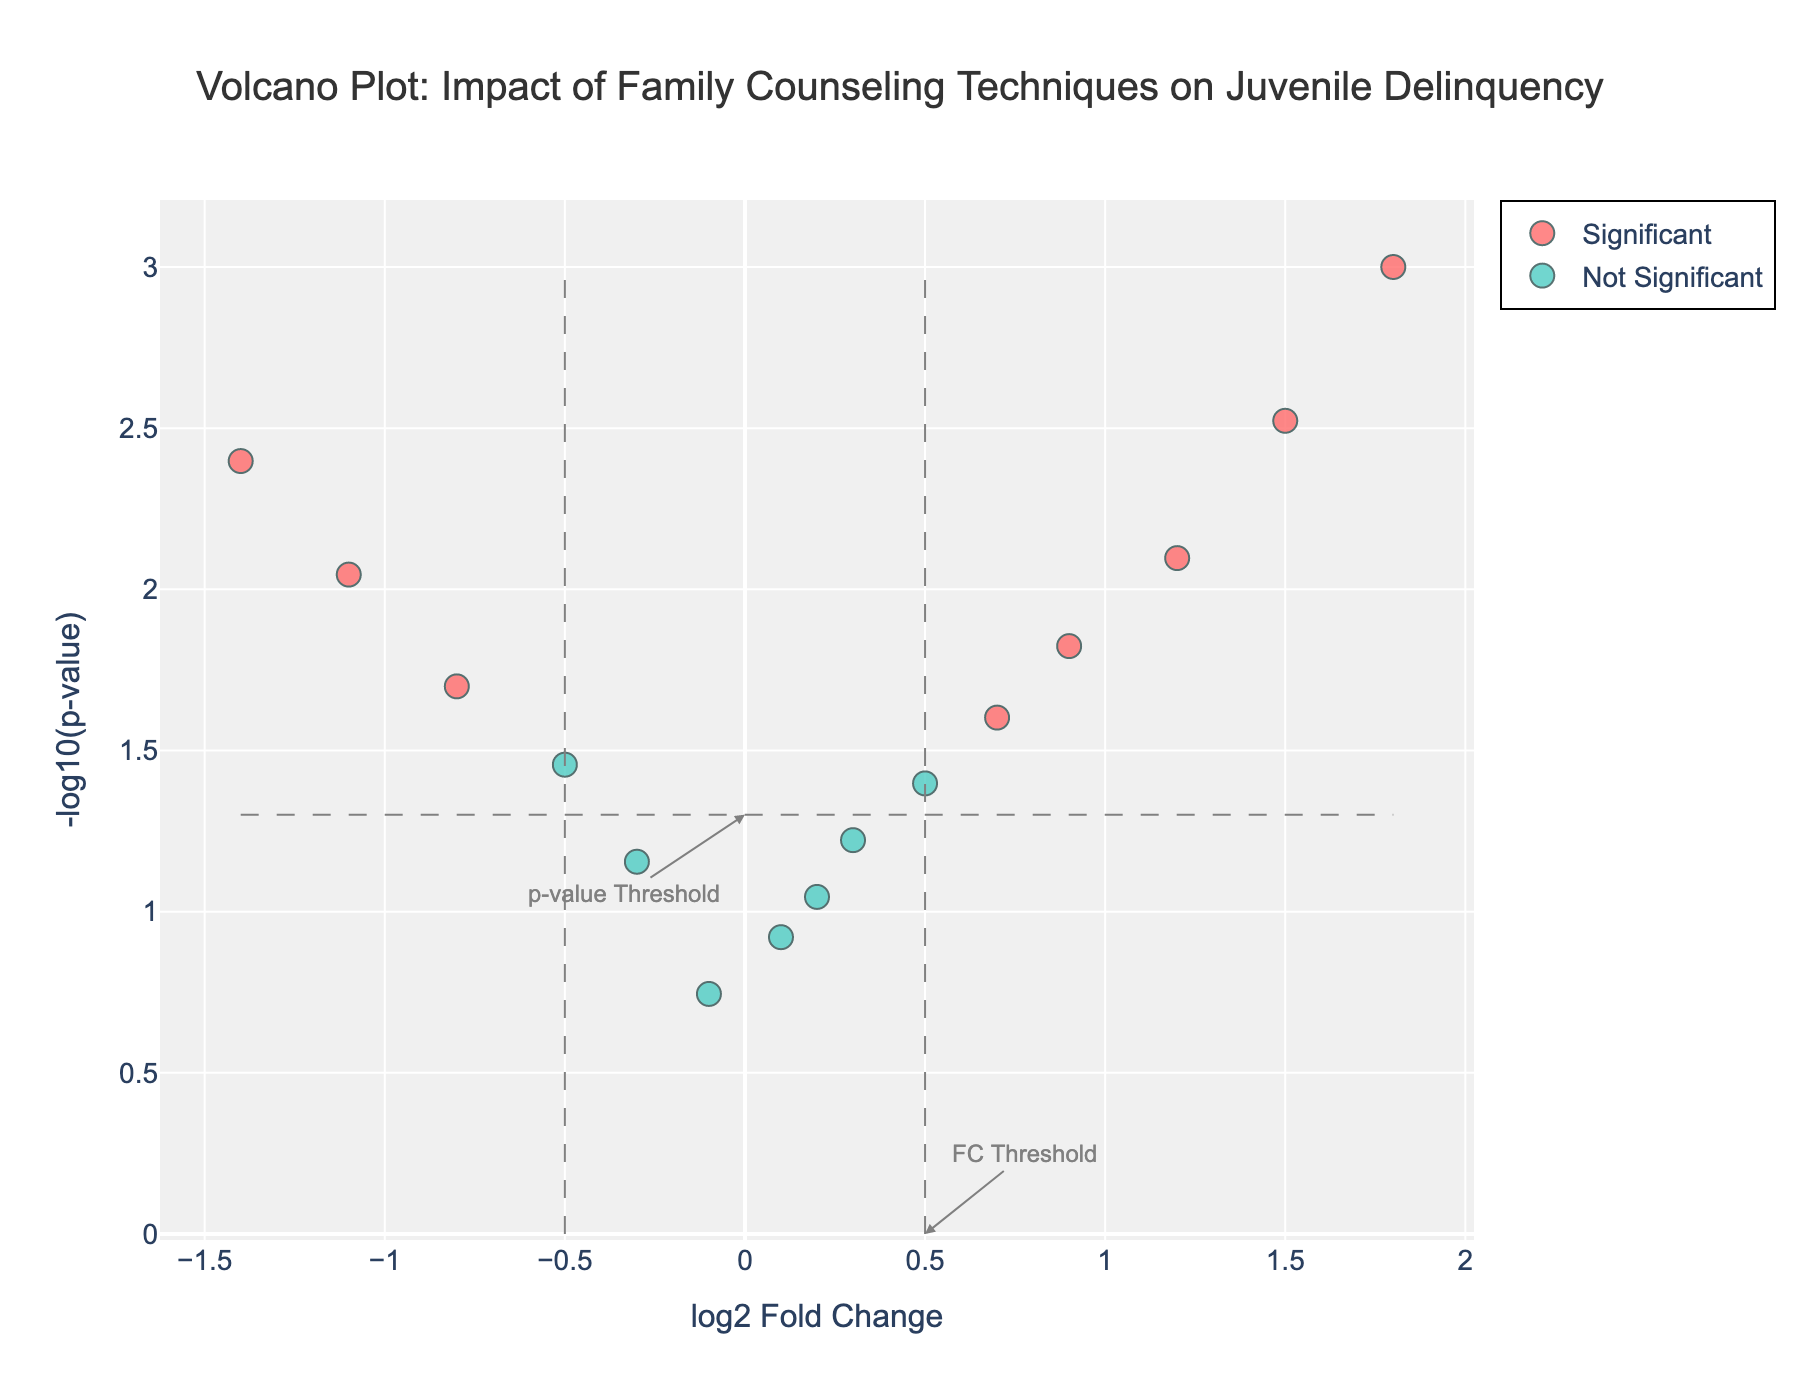What's the title of the plot? The title of the plot is located at the top center and it helps us understand the context of the data being visualized.
Answer: Volcano Plot: Impact of Family Counseling Techniques on Juvenile Delinquency How many family counseling techniques are considered significant based on the plot? Techniques are considered significant if their points are colored as 'Significant'. By counting the red points on the plot, we can determine the number of significant techniques.
Answer: 9 Which family counseling technique has the highest negative log2 Fold Change? The technique with the highest negative log2 Fold Change is the one farthest to the left on the x-axis. By identifying this point, we can determine the counseling technique.
Answer: Milan Systemic Family Therapy What is the log2 Fold Change and p-value of Multisystemic Therapy? To find the values for Multisystemic Therapy, look for its point on the plot and refer to its position on the x-axis and y-axis, along with any hover text.
Answer: log2 Fold Change = 1.8; p-value = 0.001 Which technique is closest to the FC threshold but not significant, and what is its log2 Fold Change and p-value? The FC threshold is marked by the vertical dashed line at 0.5 and -0.5 on the x-axis. Identify the technique closest to this line with 'Not Significant' color and refer to its log2 Fold Change and p-value.
Answer: Family Systems Therapy; log2 Fold Change = -0.5; p-value = 0.035 What does the vertical dashed line at log2 Fold Change = 0.5 represent? The vertical dashed line indicates the threshold for log2 Fold Change used to determine the significance, helping to visually separate significant and non-significant changes.
Answer: FC Threshold Which family counseling technique has the smallest p-value among the significant techniques? Among the significant techniques (colored red), the smallest p-value corresponds to the highest point on the y-axis, indicating the largest -log10(p-value).
Answer: Multisystemic Therapy How many techniques have a positive log2 Fold Change and are not significant? Positive log2 Fold Change values are to the right of the y-axis. Count the number of green points (Not Significant) located on the right side of the plot.
Answer: 3 